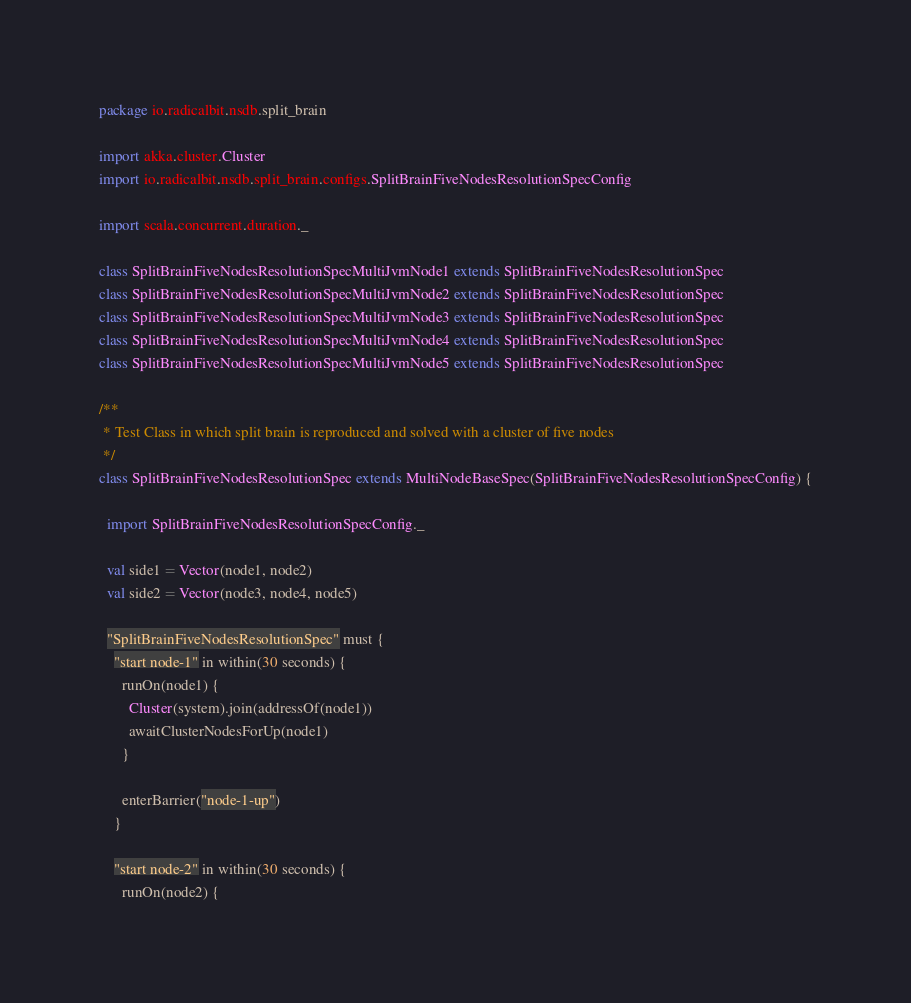<code> <loc_0><loc_0><loc_500><loc_500><_Scala_>package io.radicalbit.nsdb.split_brain

import akka.cluster.Cluster
import io.radicalbit.nsdb.split_brain.configs.SplitBrainFiveNodesResolutionSpecConfig

import scala.concurrent.duration._

class SplitBrainFiveNodesResolutionSpecMultiJvmNode1 extends SplitBrainFiveNodesResolutionSpec
class SplitBrainFiveNodesResolutionSpecMultiJvmNode2 extends SplitBrainFiveNodesResolutionSpec
class SplitBrainFiveNodesResolutionSpecMultiJvmNode3 extends SplitBrainFiveNodesResolutionSpec
class SplitBrainFiveNodesResolutionSpecMultiJvmNode4 extends SplitBrainFiveNodesResolutionSpec
class SplitBrainFiveNodesResolutionSpecMultiJvmNode5 extends SplitBrainFiveNodesResolutionSpec

/**
 * Test Class in which split brain is reproduced and solved with a cluster of five nodes
 */
class SplitBrainFiveNodesResolutionSpec extends MultiNodeBaseSpec(SplitBrainFiveNodesResolutionSpecConfig) {

  import SplitBrainFiveNodesResolutionSpecConfig._

  val side1 = Vector(node1, node2)
  val side2 = Vector(node3, node4, node5)

  "SplitBrainFiveNodesResolutionSpec" must {
    "start node-1" in within(30 seconds) {
      runOn(node1) {
        Cluster(system).join(addressOf(node1))
        awaitClusterNodesForUp(node1)
      }

      enterBarrier("node-1-up")
    }

    "start node-2" in within(30 seconds) {
      runOn(node2) {</code> 